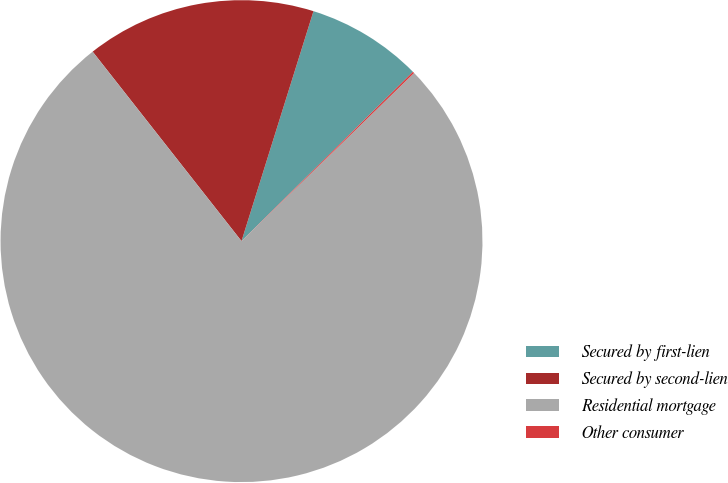Convert chart to OTSL. <chart><loc_0><loc_0><loc_500><loc_500><pie_chart><fcel>Secured by first-lien<fcel>Secured by second-lien<fcel>Residential mortgage<fcel>Other consumer<nl><fcel>7.77%<fcel>15.43%<fcel>76.7%<fcel>0.11%<nl></chart> 